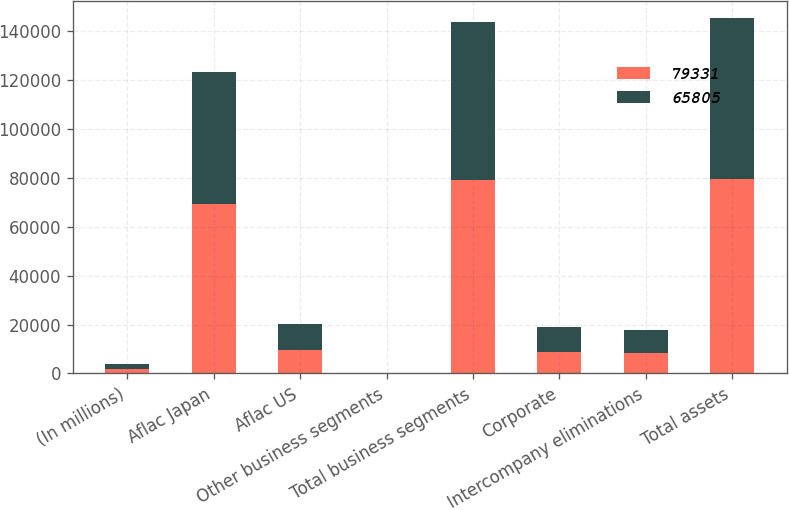Convert chart to OTSL. <chart><loc_0><loc_0><loc_500><loc_500><stacked_bar_chart><ecel><fcel>(In millions)<fcel>Aflac Japan<fcel>Aflac US<fcel>Other business segments<fcel>Total business segments<fcel>Corporate<fcel>Intercompany eliminations<fcel>Total assets<nl><fcel>79331<fcel>2008<fcel>69141<fcel>9679<fcel>166<fcel>78986<fcel>8716<fcel>8371<fcel>79331<nl><fcel>65805<fcel>2007<fcel>54153<fcel>10415<fcel>117<fcel>64685<fcel>10364<fcel>9244<fcel>65805<nl></chart> 